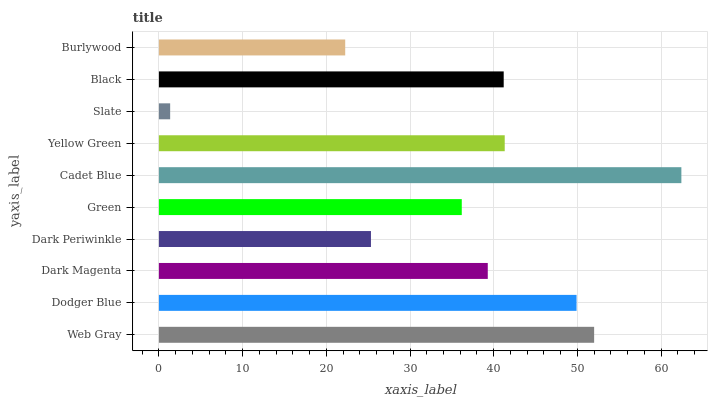Is Slate the minimum?
Answer yes or no. Yes. Is Cadet Blue the maximum?
Answer yes or no. Yes. Is Dodger Blue the minimum?
Answer yes or no. No. Is Dodger Blue the maximum?
Answer yes or no. No. Is Web Gray greater than Dodger Blue?
Answer yes or no. Yes. Is Dodger Blue less than Web Gray?
Answer yes or no. Yes. Is Dodger Blue greater than Web Gray?
Answer yes or no. No. Is Web Gray less than Dodger Blue?
Answer yes or no. No. Is Black the high median?
Answer yes or no. Yes. Is Dark Magenta the low median?
Answer yes or no. Yes. Is Yellow Green the high median?
Answer yes or no. No. Is Black the low median?
Answer yes or no. No. 